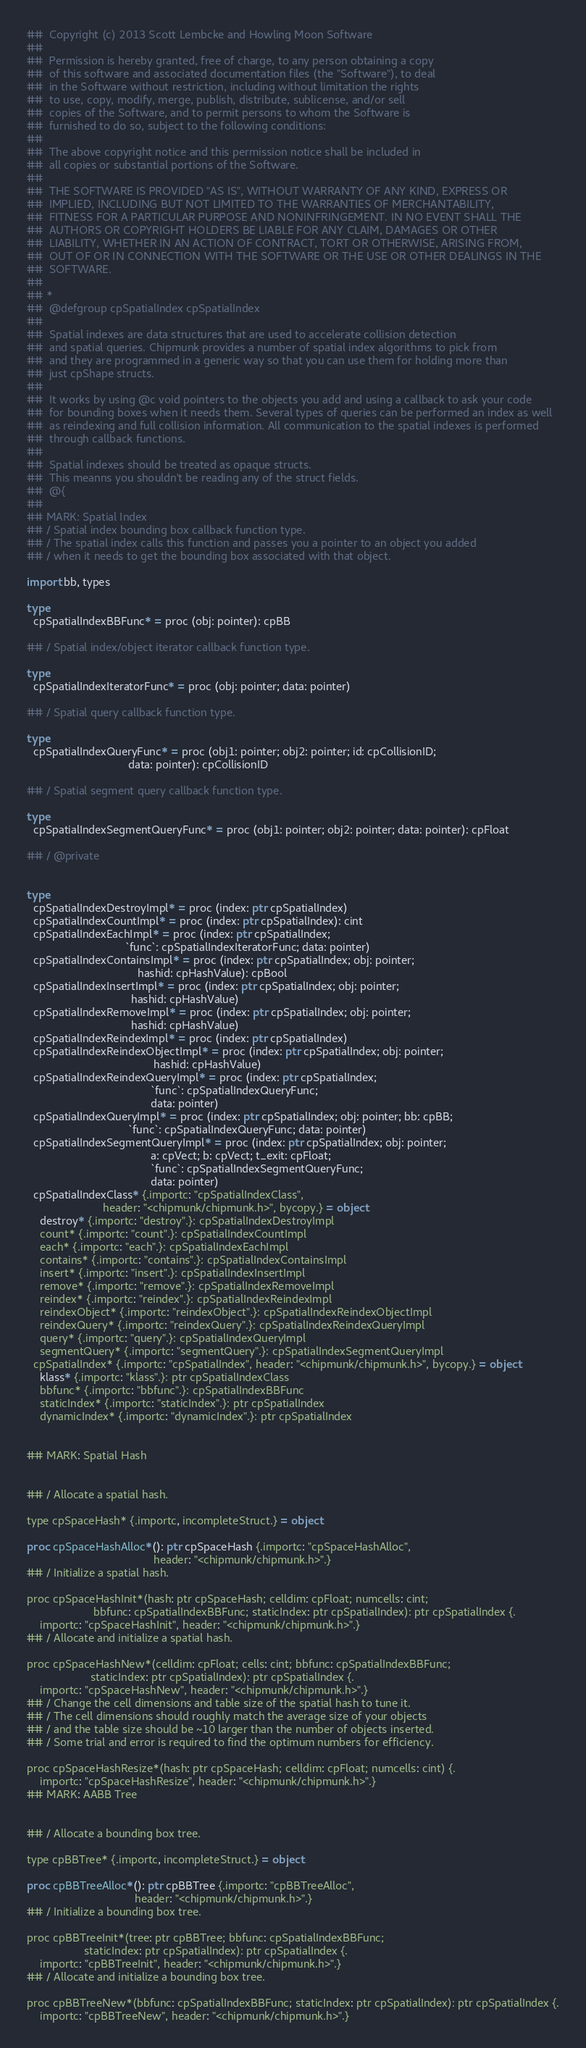<code> <loc_0><loc_0><loc_500><loc_500><_Nim_>##  Copyright (c) 2013 Scott Lembcke and Howling Moon Software
##
##  Permission is hereby granted, free of charge, to any person obtaining a copy
##  of this software and associated documentation files (the "Software"), to deal
##  in the Software without restriction, including without limitation the rights
##  to use, copy, modify, merge, publish, distribute, sublicense, and/or sell
##  copies of the Software, and to permit persons to whom the Software is
##  furnished to do so, subject to the following conditions:
##
##  The above copyright notice and this permission notice shall be included in
##  all copies or substantial portions of the Software.
##
##  THE SOFTWARE IS PROVIDED "AS IS", WITHOUT WARRANTY OF ANY KIND, EXPRESS OR
##  IMPLIED, INCLUDING BUT NOT LIMITED TO THE WARRANTIES OF MERCHANTABILITY,
##  FITNESS FOR A PARTICULAR PURPOSE AND NONINFRINGEMENT. IN NO EVENT SHALL THE
##  AUTHORS OR COPYRIGHT HOLDERS BE LIABLE FOR ANY CLAIM, DAMAGES OR OTHER
##  LIABILITY, WHETHER IN AN ACTION OF CONTRACT, TORT OR OTHERWISE, ARISING FROM,
##  OUT OF OR IN CONNECTION WITH THE SOFTWARE OR THE USE OR OTHER DEALINGS IN THE
##  SOFTWARE.
##
## *
## 	@defgroup cpSpatialIndex cpSpatialIndex
## 	
## 	Spatial indexes are data structures that are used to accelerate collision detection
## 	and spatial queries. Chipmunk provides a number of spatial index algorithms to pick from
## 	and they are programmed in a generic way so that you can use them for holding more than
## 	just cpShape structs.
## 	
## 	It works by using @c void pointers to the objects you add and using a callback to ask your code
## 	for bounding boxes when it needs them. Several types of queries can be performed an index as well
## 	as reindexing and full collision information. All communication to the spatial indexes is performed
## 	through callback functions.
## 	
## 	Spatial indexes should be treated as opaque structs.
## 	This meanns you shouldn't be reading any of the struct fields.
## 	@{
##
## MARK: Spatial Index
## / Spatial index bounding box callback function type.
## / The spatial index calls this function and passes you a pointer to an object you added
## / when it needs to get the bounding box associated with that object.

import bb, types

type
  cpSpatialIndexBBFunc* = proc (obj: pointer): cpBB

## / Spatial index/object iterator callback function type.

type
  cpSpatialIndexIteratorFunc* = proc (obj: pointer; data: pointer)

## / Spatial query callback function type.

type
  cpSpatialIndexQueryFunc* = proc (obj1: pointer; obj2: pointer; id: cpCollisionID;
                                data: pointer): cpCollisionID

## / Spatial segment query callback function type.

type
  cpSpatialIndexSegmentQueryFunc* = proc (obj1: pointer; obj2: pointer; data: pointer): cpFloat

## / @private


type
  cpSpatialIndexDestroyImpl* = proc (index: ptr cpSpatialIndex)
  cpSpatialIndexCountImpl* = proc (index: ptr cpSpatialIndex): cint
  cpSpatialIndexEachImpl* = proc (index: ptr cpSpatialIndex;
                               `func`: cpSpatialIndexIteratorFunc; data: pointer)
  cpSpatialIndexContainsImpl* = proc (index: ptr cpSpatialIndex; obj: pointer;
                                   hashid: cpHashValue): cpBool
  cpSpatialIndexInsertImpl* = proc (index: ptr cpSpatialIndex; obj: pointer;
                                 hashid: cpHashValue)
  cpSpatialIndexRemoveImpl* = proc (index: ptr cpSpatialIndex; obj: pointer;
                                 hashid: cpHashValue)
  cpSpatialIndexReindexImpl* = proc (index: ptr cpSpatialIndex)
  cpSpatialIndexReindexObjectImpl* = proc (index: ptr cpSpatialIndex; obj: pointer;
                                        hashid: cpHashValue)
  cpSpatialIndexReindexQueryImpl* = proc (index: ptr cpSpatialIndex;
                                       `func`: cpSpatialIndexQueryFunc;
                                       data: pointer)
  cpSpatialIndexQueryImpl* = proc (index: ptr cpSpatialIndex; obj: pointer; bb: cpBB;
                                `func`: cpSpatialIndexQueryFunc; data: pointer)
  cpSpatialIndexSegmentQueryImpl* = proc (index: ptr cpSpatialIndex; obj: pointer;
                                       a: cpVect; b: cpVect; t_exit: cpFloat;
                                       `func`: cpSpatialIndexSegmentQueryFunc;
                                       data: pointer)
  cpSpatialIndexClass* {.importc: "cpSpatialIndexClass",
                        header: "<chipmunk/chipmunk.h>", bycopy.} = object
    destroy* {.importc: "destroy".}: cpSpatialIndexDestroyImpl
    count* {.importc: "count".}: cpSpatialIndexCountImpl
    each* {.importc: "each".}: cpSpatialIndexEachImpl
    contains* {.importc: "contains".}: cpSpatialIndexContainsImpl
    insert* {.importc: "insert".}: cpSpatialIndexInsertImpl
    remove* {.importc: "remove".}: cpSpatialIndexRemoveImpl
    reindex* {.importc: "reindex".}: cpSpatialIndexReindexImpl
    reindexObject* {.importc: "reindexObject".}: cpSpatialIndexReindexObjectImpl
    reindexQuery* {.importc: "reindexQuery".}: cpSpatialIndexReindexQueryImpl
    query* {.importc: "query".}: cpSpatialIndexQueryImpl
    segmentQuery* {.importc: "segmentQuery".}: cpSpatialIndexSegmentQueryImpl
  cpSpatialIndex* {.importc: "cpSpatialIndex", header: "<chipmunk/chipmunk.h>", bycopy.} = object
    klass* {.importc: "klass".}: ptr cpSpatialIndexClass
    bbfunc* {.importc: "bbfunc".}: cpSpatialIndexBBFunc
    staticIndex* {.importc: "staticIndex".}: ptr cpSpatialIndex
    dynamicIndex* {.importc: "dynamicIndex".}: ptr cpSpatialIndex


## MARK: Spatial Hash


## / Allocate a spatial hash.

type cpSpaceHash* {.importc, incompleteStruct.} = object

proc cpSpaceHashAlloc*(): ptr cpSpaceHash {.importc: "cpSpaceHashAlloc",
                                        header: "<chipmunk/chipmunk.h>".}
## / Initialize a spatial hash.

proc cpSpaceHashInit*(hash: ptr cpSpaceHash; celldim: cpFloat; numcells: cint;
                     bbfunc: cpSpatialIndexBBFunc; staticIndex: ptr cpSpatialIndex): ptr cpSpatialIndex {.
    importc: "cpSpaceHashInit", header: "<chipmunk/chipmunk.h>".}
## / Allocate and initialize a spatial hash.

proc cpSpaceHashNew*(celldim: cpFloat; cells: cint; bbfunc: cpSpatialIndexBBFunc;
                    staticIndex: ptr cpSpatialIndex): ptr cpSpatialIndex {.
    importc: "cpSpaceHashNew", header: "<chipmunk/chipmunk.h>".}
## / Change the cell dimensions and table size of the spatial hash to tune it.
## / The cell dimensions should roughly match the average size of your objects
## / and the table size should be ~10 larger than the number of objects inserted.
## / Some trial and error is required to find the optimum numbers for efficiency.

proc cpSpaceHashResize*(hash: ptr cpSpaceHash; celldim: cpFloat; numcells: cint) {.
    importc: "cpSpaceHashResize", header: "<chipmunk/chipmunk.h>".}
## MARK: AABB Tree


## / Allocate a bounding box tree.

type cpBBTree* {.importc, incompleteStruct.} = object

proc cpBBTreeAlloc*(): ptr cpBBTree {.importc: "cpBBTreeAlloc",
                                  header: "<chipmunk/chipmunk.h>".}
## / Initialize a bounding box tree.

proc cpBBTreeInit*(tree: ptr cpBBTree; bbfunc: cpSpatialIndexBBFunc;
                  staticIndex: ptr cpSpatialIndex): ptr cpSpatialIndex {.
    importc: "cpBBTreeInit", header: "<chipmunk/chipmunk.h>".}
## / Allocate and initialize a bounding box tree.

proc cpBBTreeNew*(bbfunc: cpSpatialIndexBBFunc; staticIndex: ptr cpSpatialIndex): ptr cpSpatialIndex {.
    importc: "cpBBTreeNew", header: "<chipmunk/chipmunk.h>".}</code> 